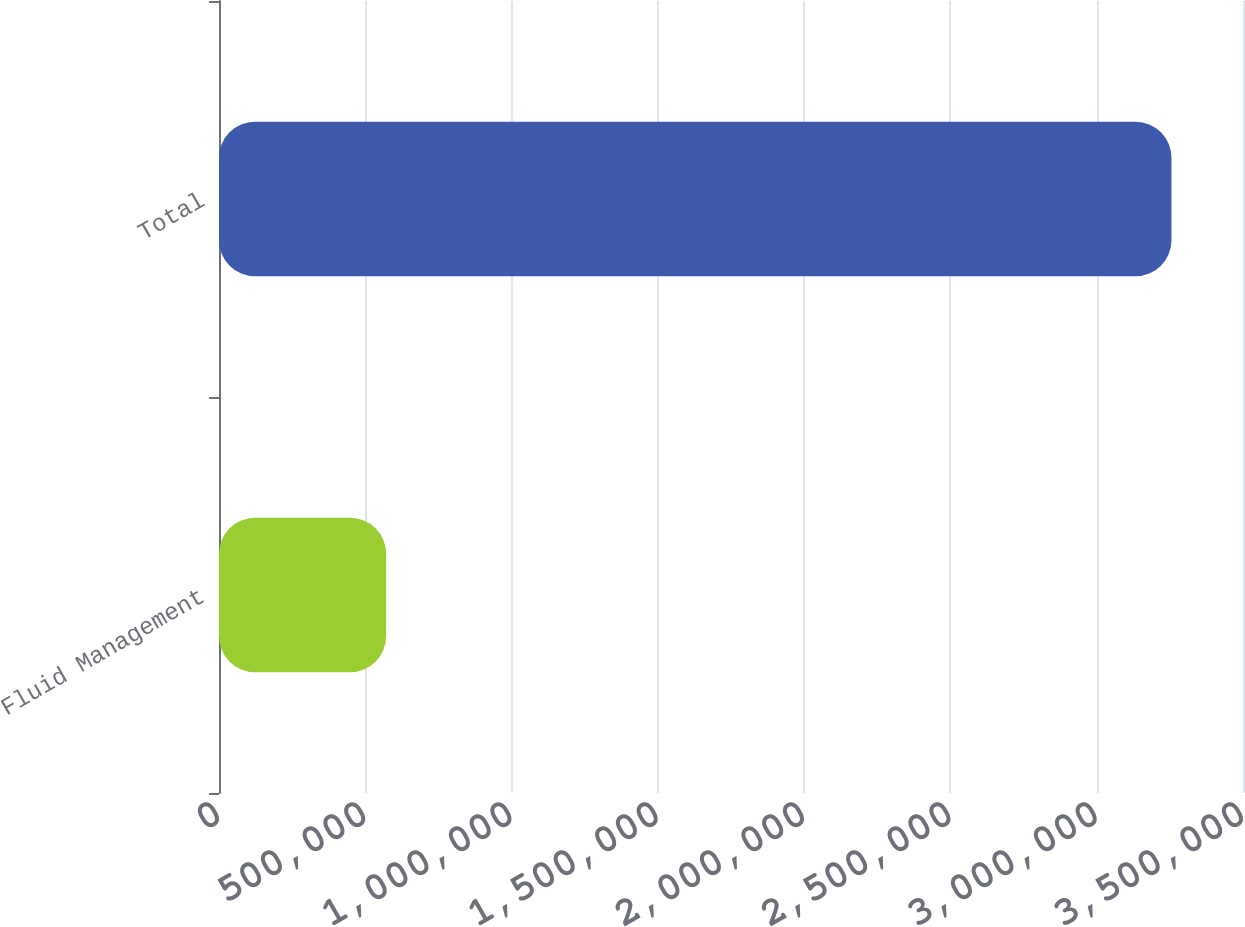<chart> <loc_0><loc_0><loc_500><loc_500><bar_chart><fcel>Fluid Management<fcel>Total<nl><fcel>571221<fcel>3.25557e+06<nl></chart> 